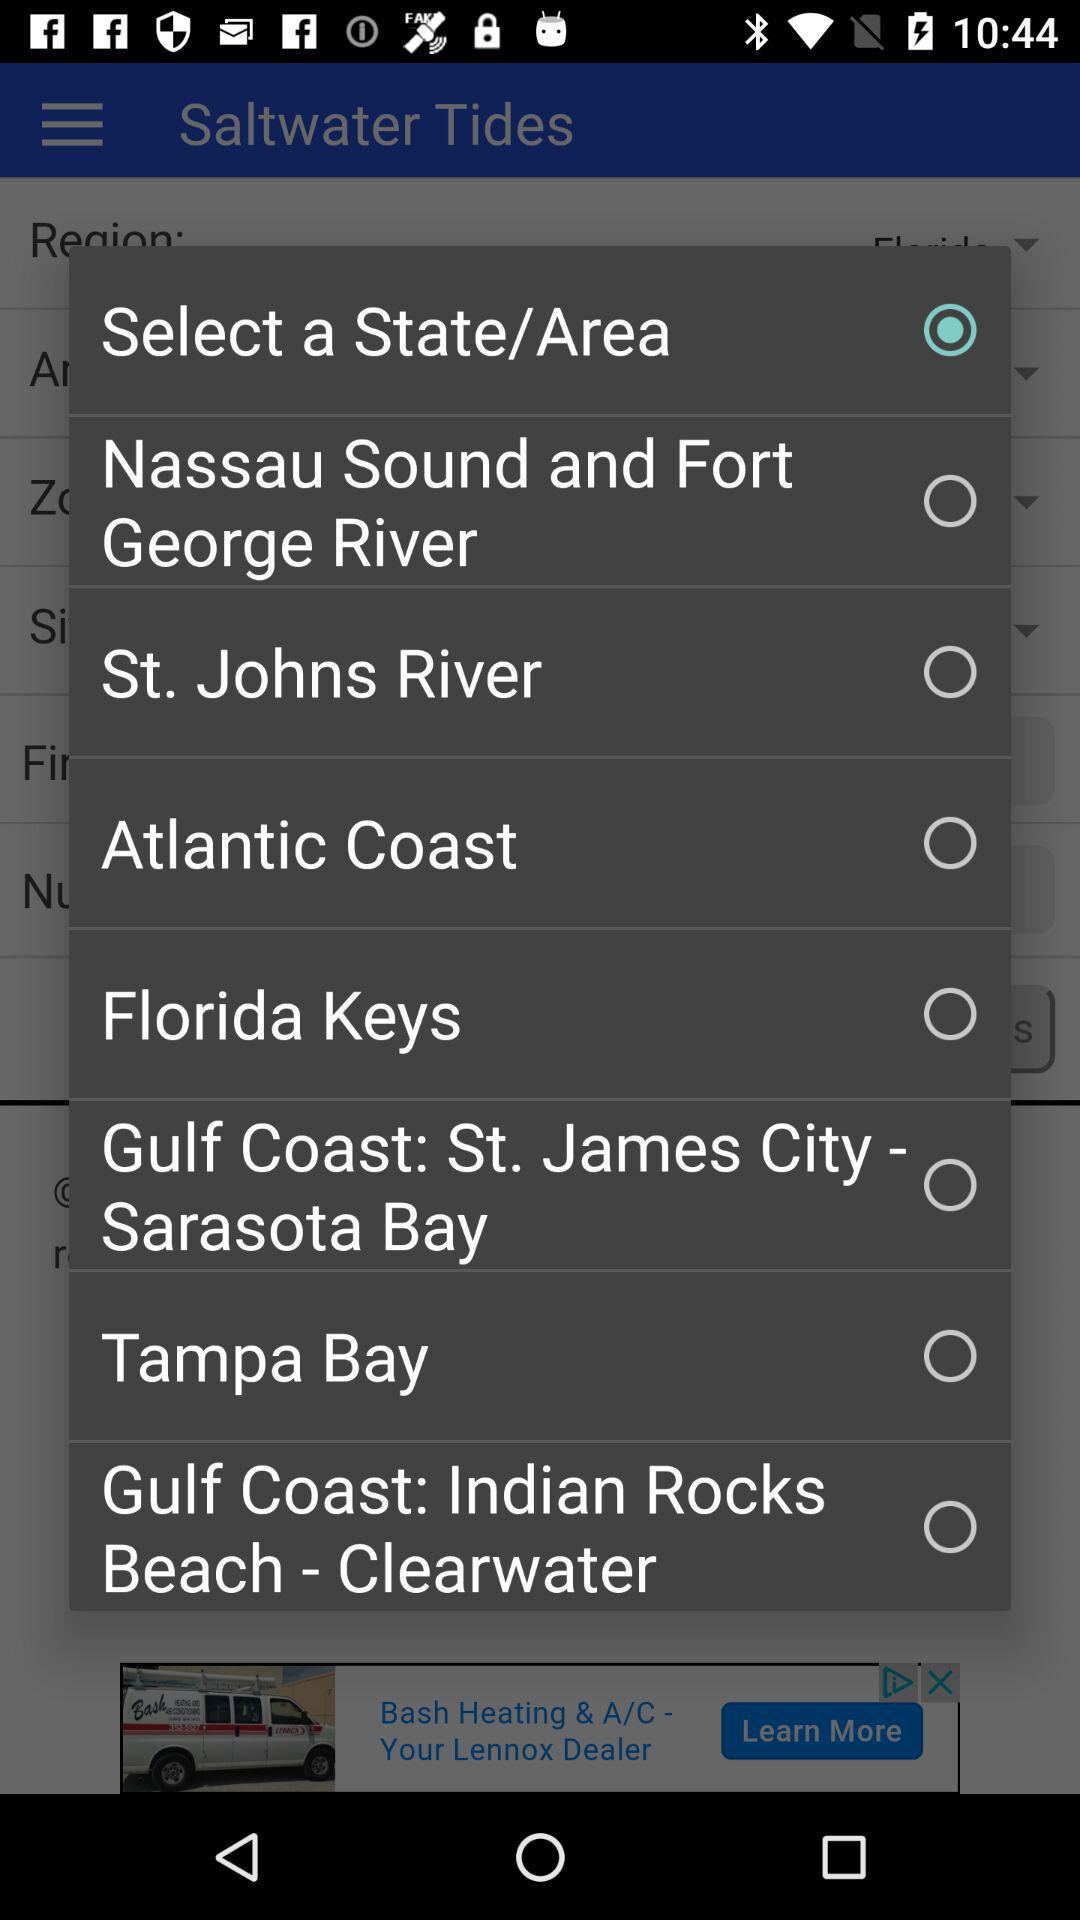Which option is selected? The selected option is "Select a State/Area". 